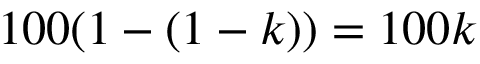Convert formula to latex. <formula><loc_0><loc_0><loc_500><loc_500>1 0 0 ( 1 - ( 1 - k ) ) = 1 0 0 k \</formula> 